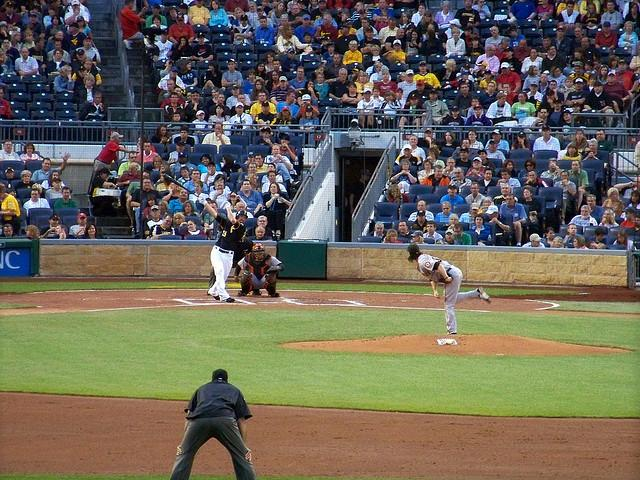What does the man in the center of the field want to achieve? Please explain your reasoning. strike. The pitcher is going to try to get the batter out. 